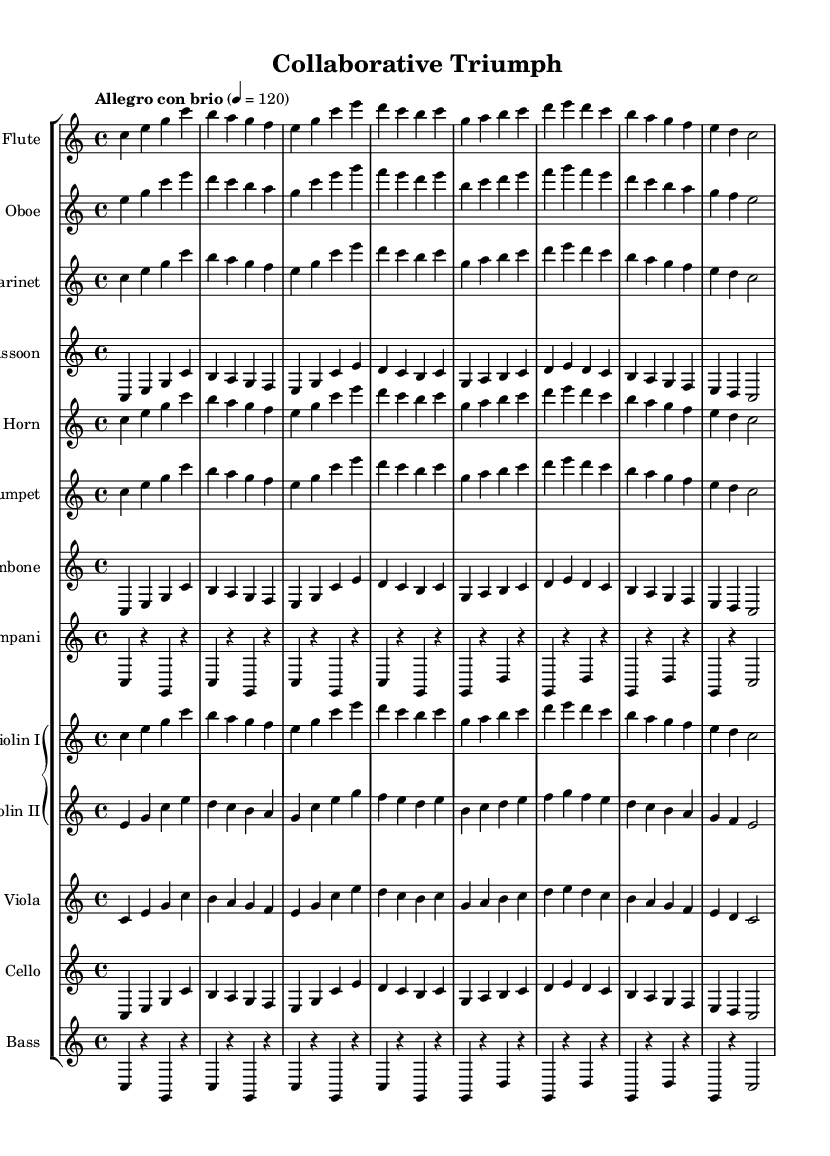What is the key signature of this music? The key signature is indicated before the start of the staff. In this case, there are no sharps or flats present, indicating C major.
Answer: C major What is the time signature of this music? The time signature is located at the beginning of the score, shown as a "4/4". This indicates that there are four beats in one measure and that a quarter note receives one beat.
Answer: 4/4 What is the tempo marking for this piece? The tempo marking is shown above the staff as "Allegro con brio". This indicates a fast and lively pace for the piece.
Answer: Allegro con brio How many measures are in the first section of the music? By counting the notation in the flute part, we can identify the distinct groups of four beats that make up each measure. The first section contains eight measures.
Answer: 8 Identify two woodwind instruments used in this symphony. The woodwind instruments are written as part of the score, explicitly listing "Flute" and "Oboe" among others.
Answer: Flute, Oboe Which section of the orchestra features string instruments? The string instruments are grouped in a specific section of the score known as the "Grand Staff," where instruments like "Violin I," "Violin II," "Viola," "Cello," and "Bass" are included.
Answer: String section What dynamic markings can be inferred for this piece? The tempo marking "Allegro con brio" suggests an energetic dynamic, typically indicating a lively and bright sound. While no explicit dynamic markings are present, this tempo implies a generally strong dynamic level.
Answer: Strong dynamic 